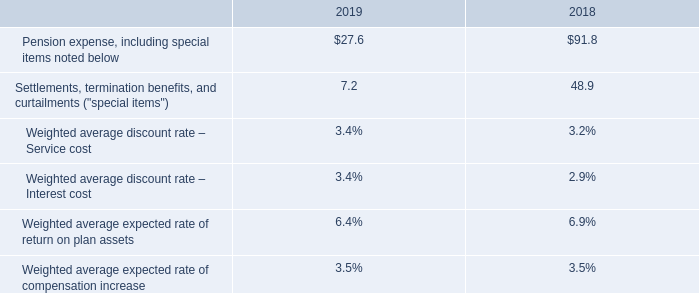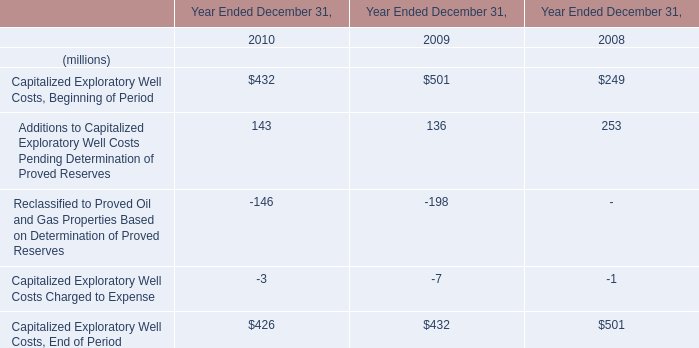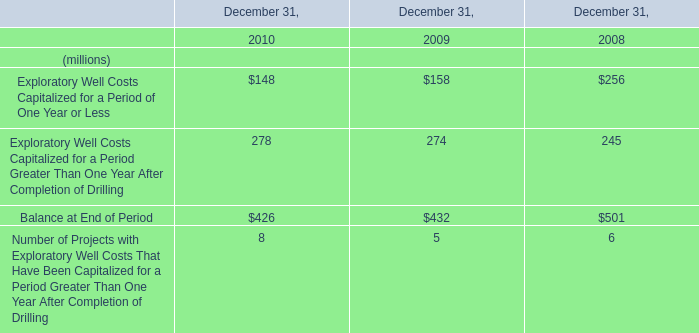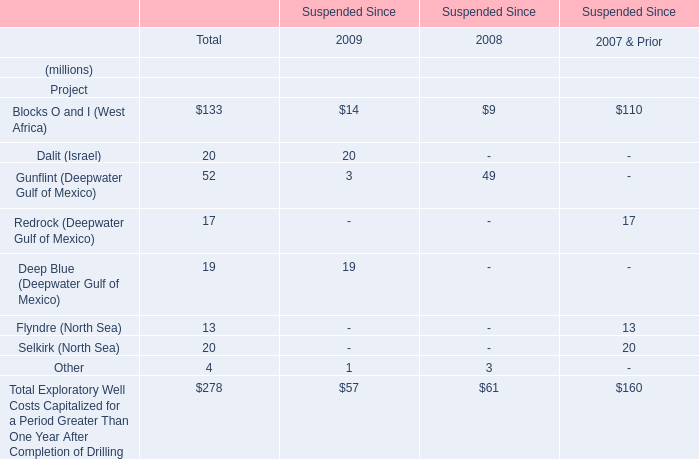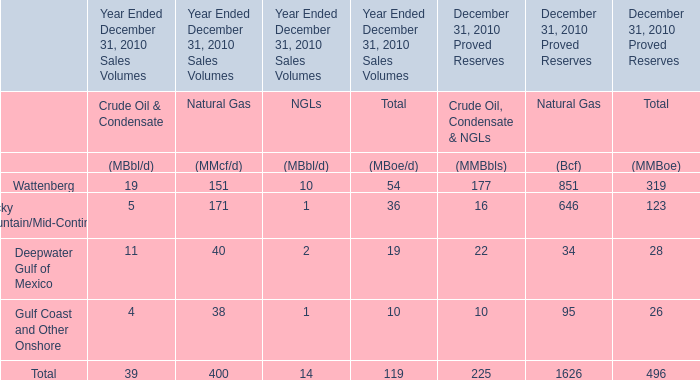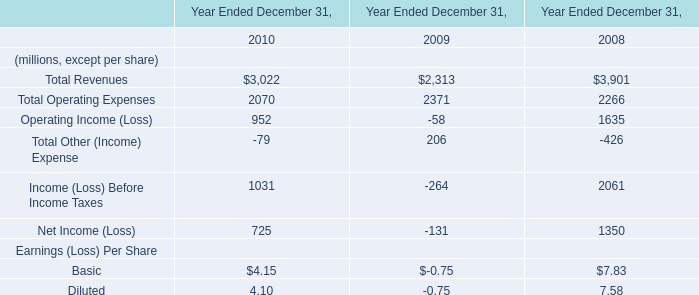How many kinds of December 31 are greater than 200 in 2010? 
Answer: 2. 